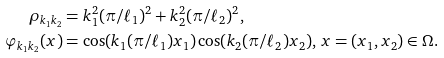Convert formula to latex. <formula><loc_0><loc_0><loc_500><loc_500>\rho _ { k _ { 1 } k _ { 2 } } & = k _ { 1 } ^ { 2 } ( \pi / \ell _ { 1 } ) ^ { 2 } + k _ { 2 } ^ { 2 } ( \pi / \ell _ { 2 } ) ^ { 2 } , \\ \varphi _ { k _ { 1 } k _ { 2 } } ( x ) & = \cos ( k _ { 1 } ( \pi / \ell _ { 1 } ) x _ { 1 } ) \cos ( k _ { 2 } ( \pi / \ell _ { 2 } ) x _ { 2 } ) , \, x = ( x _ { 1 } , x _ { 2 } ) \in \Omega .</formula> 